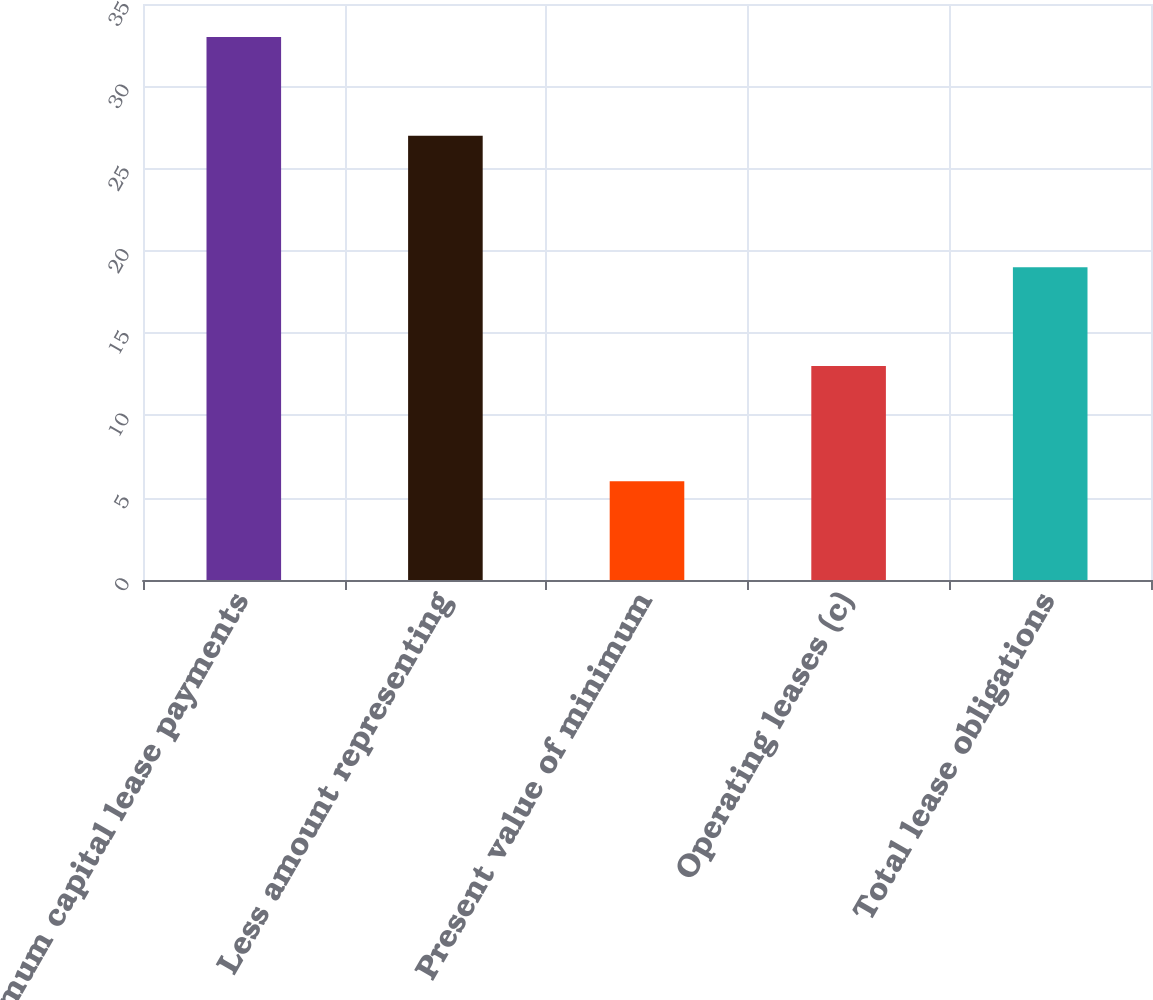Convert chart to OTSL. <chart><loc_0><loc_0><loc_500><loc_500><bar_chart><fcel>Minimum capital lease payments<fcel>Less amount representing<fcel>Present value of minimum<fcel>Operating leases (c)<fcel>Total lease obligations<nl><fcel>33<fcel>27<fcel>6<fcel>13<fcel>19<nl></chart> 